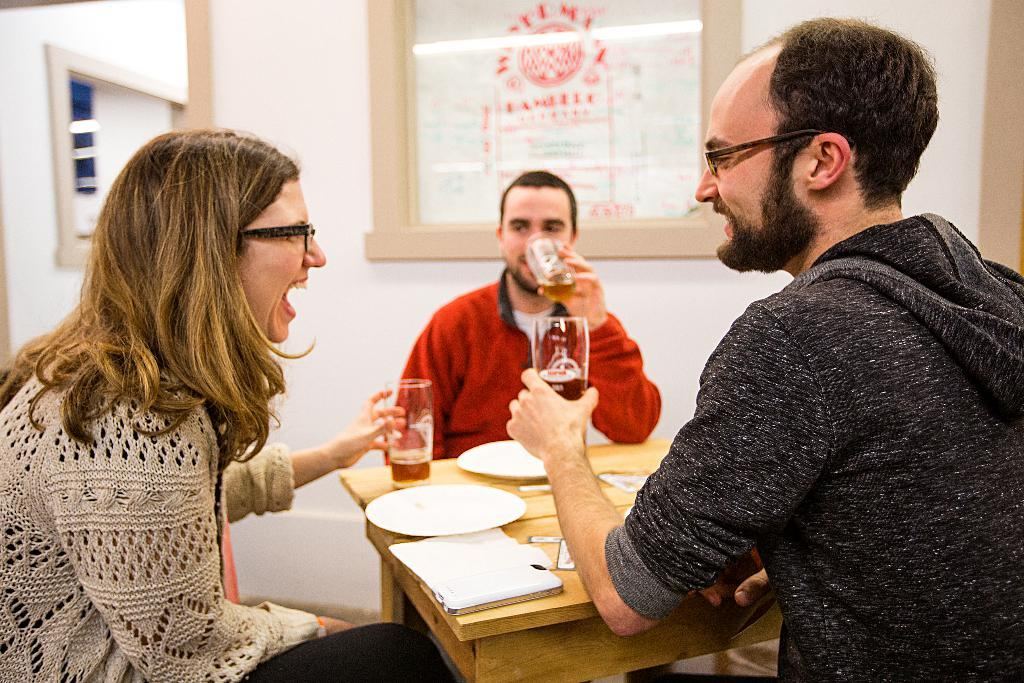How many people are in the image? There are three individuals in the image: two men and a woman. What are the three individuals doing in the image? The three individuals are sitting in front of a table. What can be seen on the table in the image? There are many items on the table. Can you describe the loaf of bread on the table in the image? There is no loaf of bread present in the image. How does the earthquake affect the three individuals in the image? There is no earthquake depicted in the image; the individuals are sitting calmly in front of the table. 